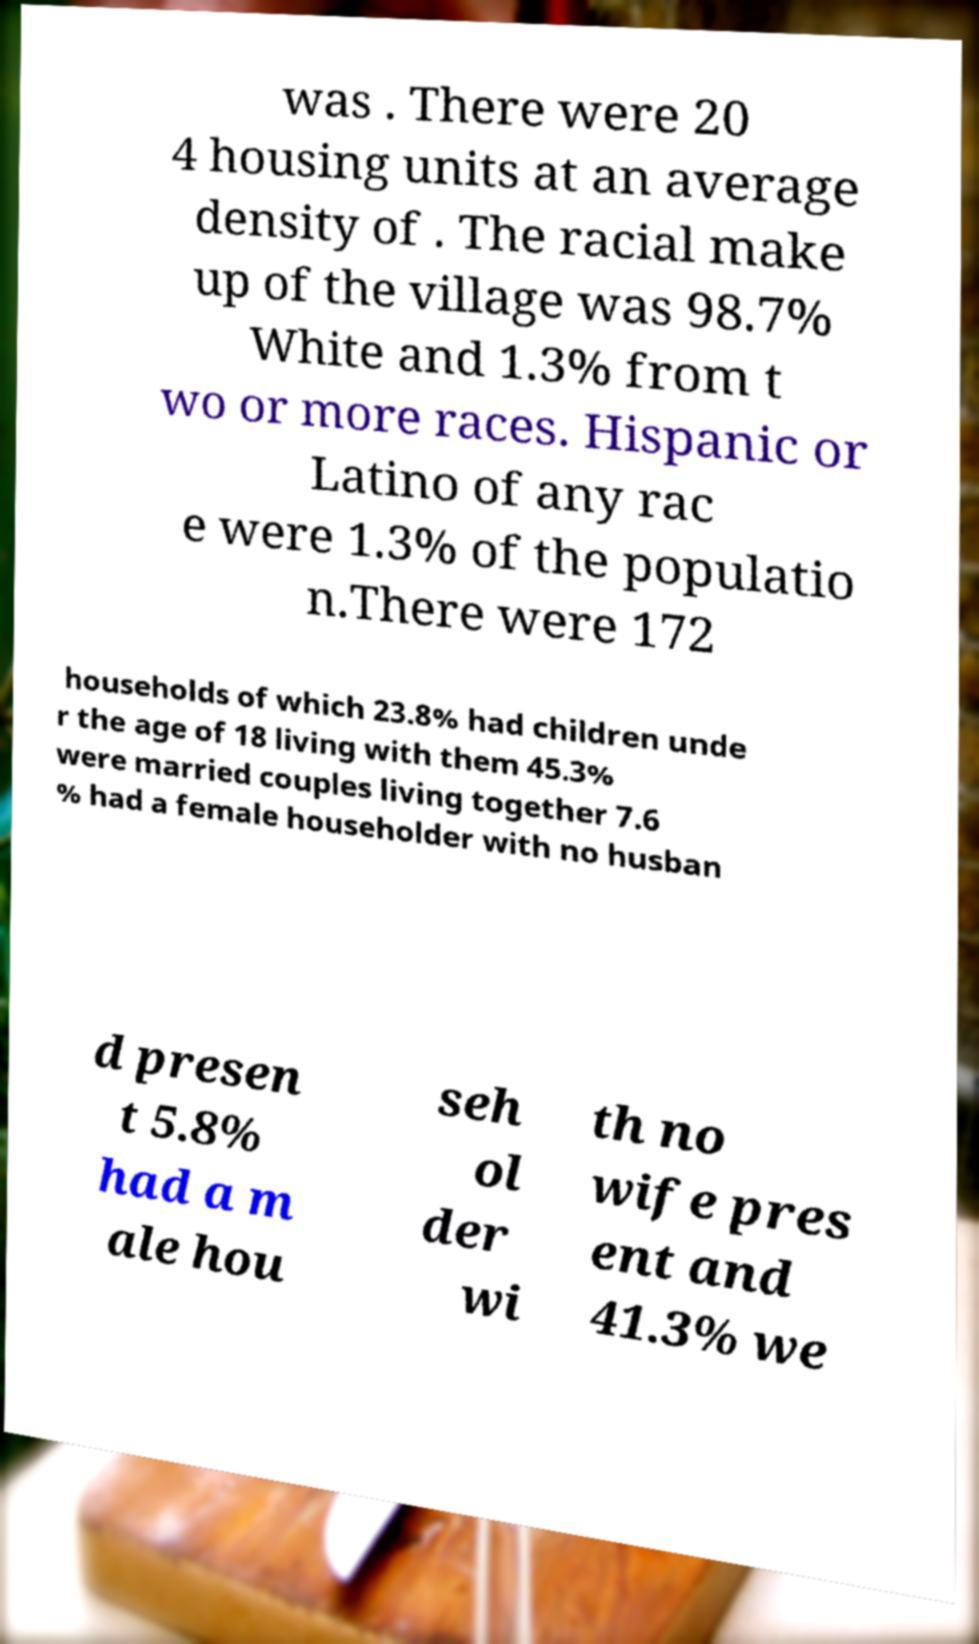Can you accurately transcribe the text from the provided image for me? was . There were 20 4 housing units at an average density of . The racial make up of the village was 98.7% White and 1.3% from t wo or more races. Hispanic or Latino of any rac e were 1.3% of the populatio n.There were 172 households of which 23.8% had children unde r the age of 18 living with them 45.3% were married couples living together 7.6 % had a female householder with no husban d presen t 5.8% had a m ale hou seh ol der wi th no wife pres ent and 41.3% we 